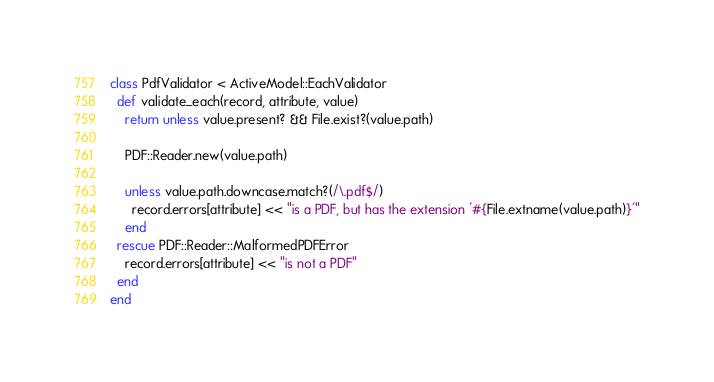Convert code to text. <code><loc_0><loc_0><loc_500><loc_500><_Ruby_>class PdfValidator < ActiveModel::EachValidator
  def validate_each(record, attribute, value)
    return unless value.present? && File.exist?(value.path)

    PDF::Reader.new(value.path)

    unless value.path.downcase.match?(/\.pdf$/)
      record.errors[attribute] << "is a PDF, but has the extension '#{File.extname(value.path)}'"
    end
  rescue PDF::Reader::MalformedPDFError
    record.errors[attribute] << "is not a PDF"
  end
end
</code> 